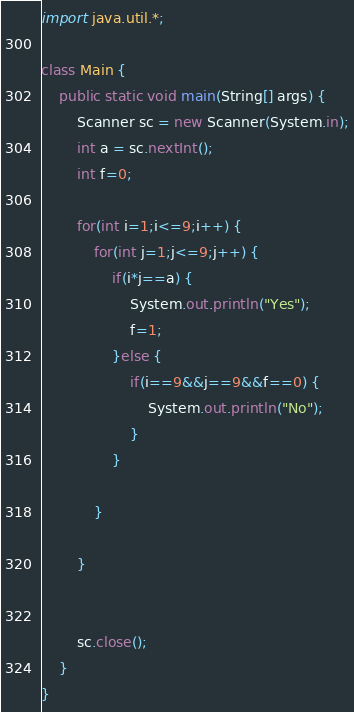Convert code to text. <code><loc_0><loc_0><loc_500><loc_500><_Java_>import java.util.*;
 
class Main {
	public static void main(String[] args) {
		Scanner sc = new Scanner(System.in);
		int a = sc.nextInt();
		int f=0;
		
		for(int i=1;i<=9;i++) {
			for(int j=1;j<=9;j++) {
				if(i*j==a) {
					System.out.println("Yes");
					f=1;
				}else {
					if(i==9&&j==9&&f==0) {
						System.out.println("No");
					}
				}

			}

		}

 
		sc.close();
	}
}</code> 